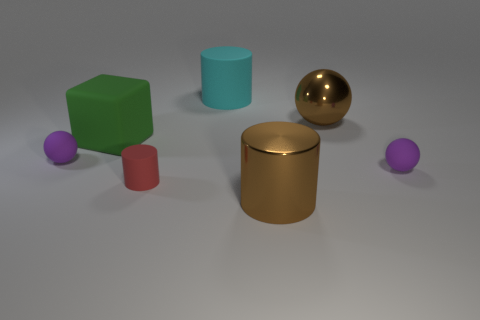There is a large brown metal cylinder right of the purple rubber sphere that is on the left side of the green matte object; is there a big green cube behind it?
Offer a terse response. Yes. There is a big cyan object that is the same shape as the small red matte thing; what is its material?
Your response must be concise. Rubber. There is a small rubber object that is left of the tiny red object; what color is it?
Your answer should be very brief. Purple. The cyan rubber thing is what size?
Provide a succinct answer. Large. Do the metallic cylinder and the brown object that is behind the red matte thing have the same size?
Ensure brevity in your answer.  Yes. There is a big object in front of the purple matte object on the left side of the matte cylinder in front of the large green object; what color is it?
Provide a succinct answer. Brown. Is the purple object that is to the right of the cyan rubber object made of the same material as the big green cube?
Provide a succinct answer. Yes. What number of other objects are the same material as the green cube?
Offer a terse response. 4. There is a brown cylinder that is the same size as the brown ball; what is it made of?
Give a very brief answer. Metal. There is a purple rubber thing that is on the left side of the big cyan matte cylinder; is its shape the same as the big brown metal thing to the left of the brown shiny sphere?
Ensure brevity in your answer.  No. 